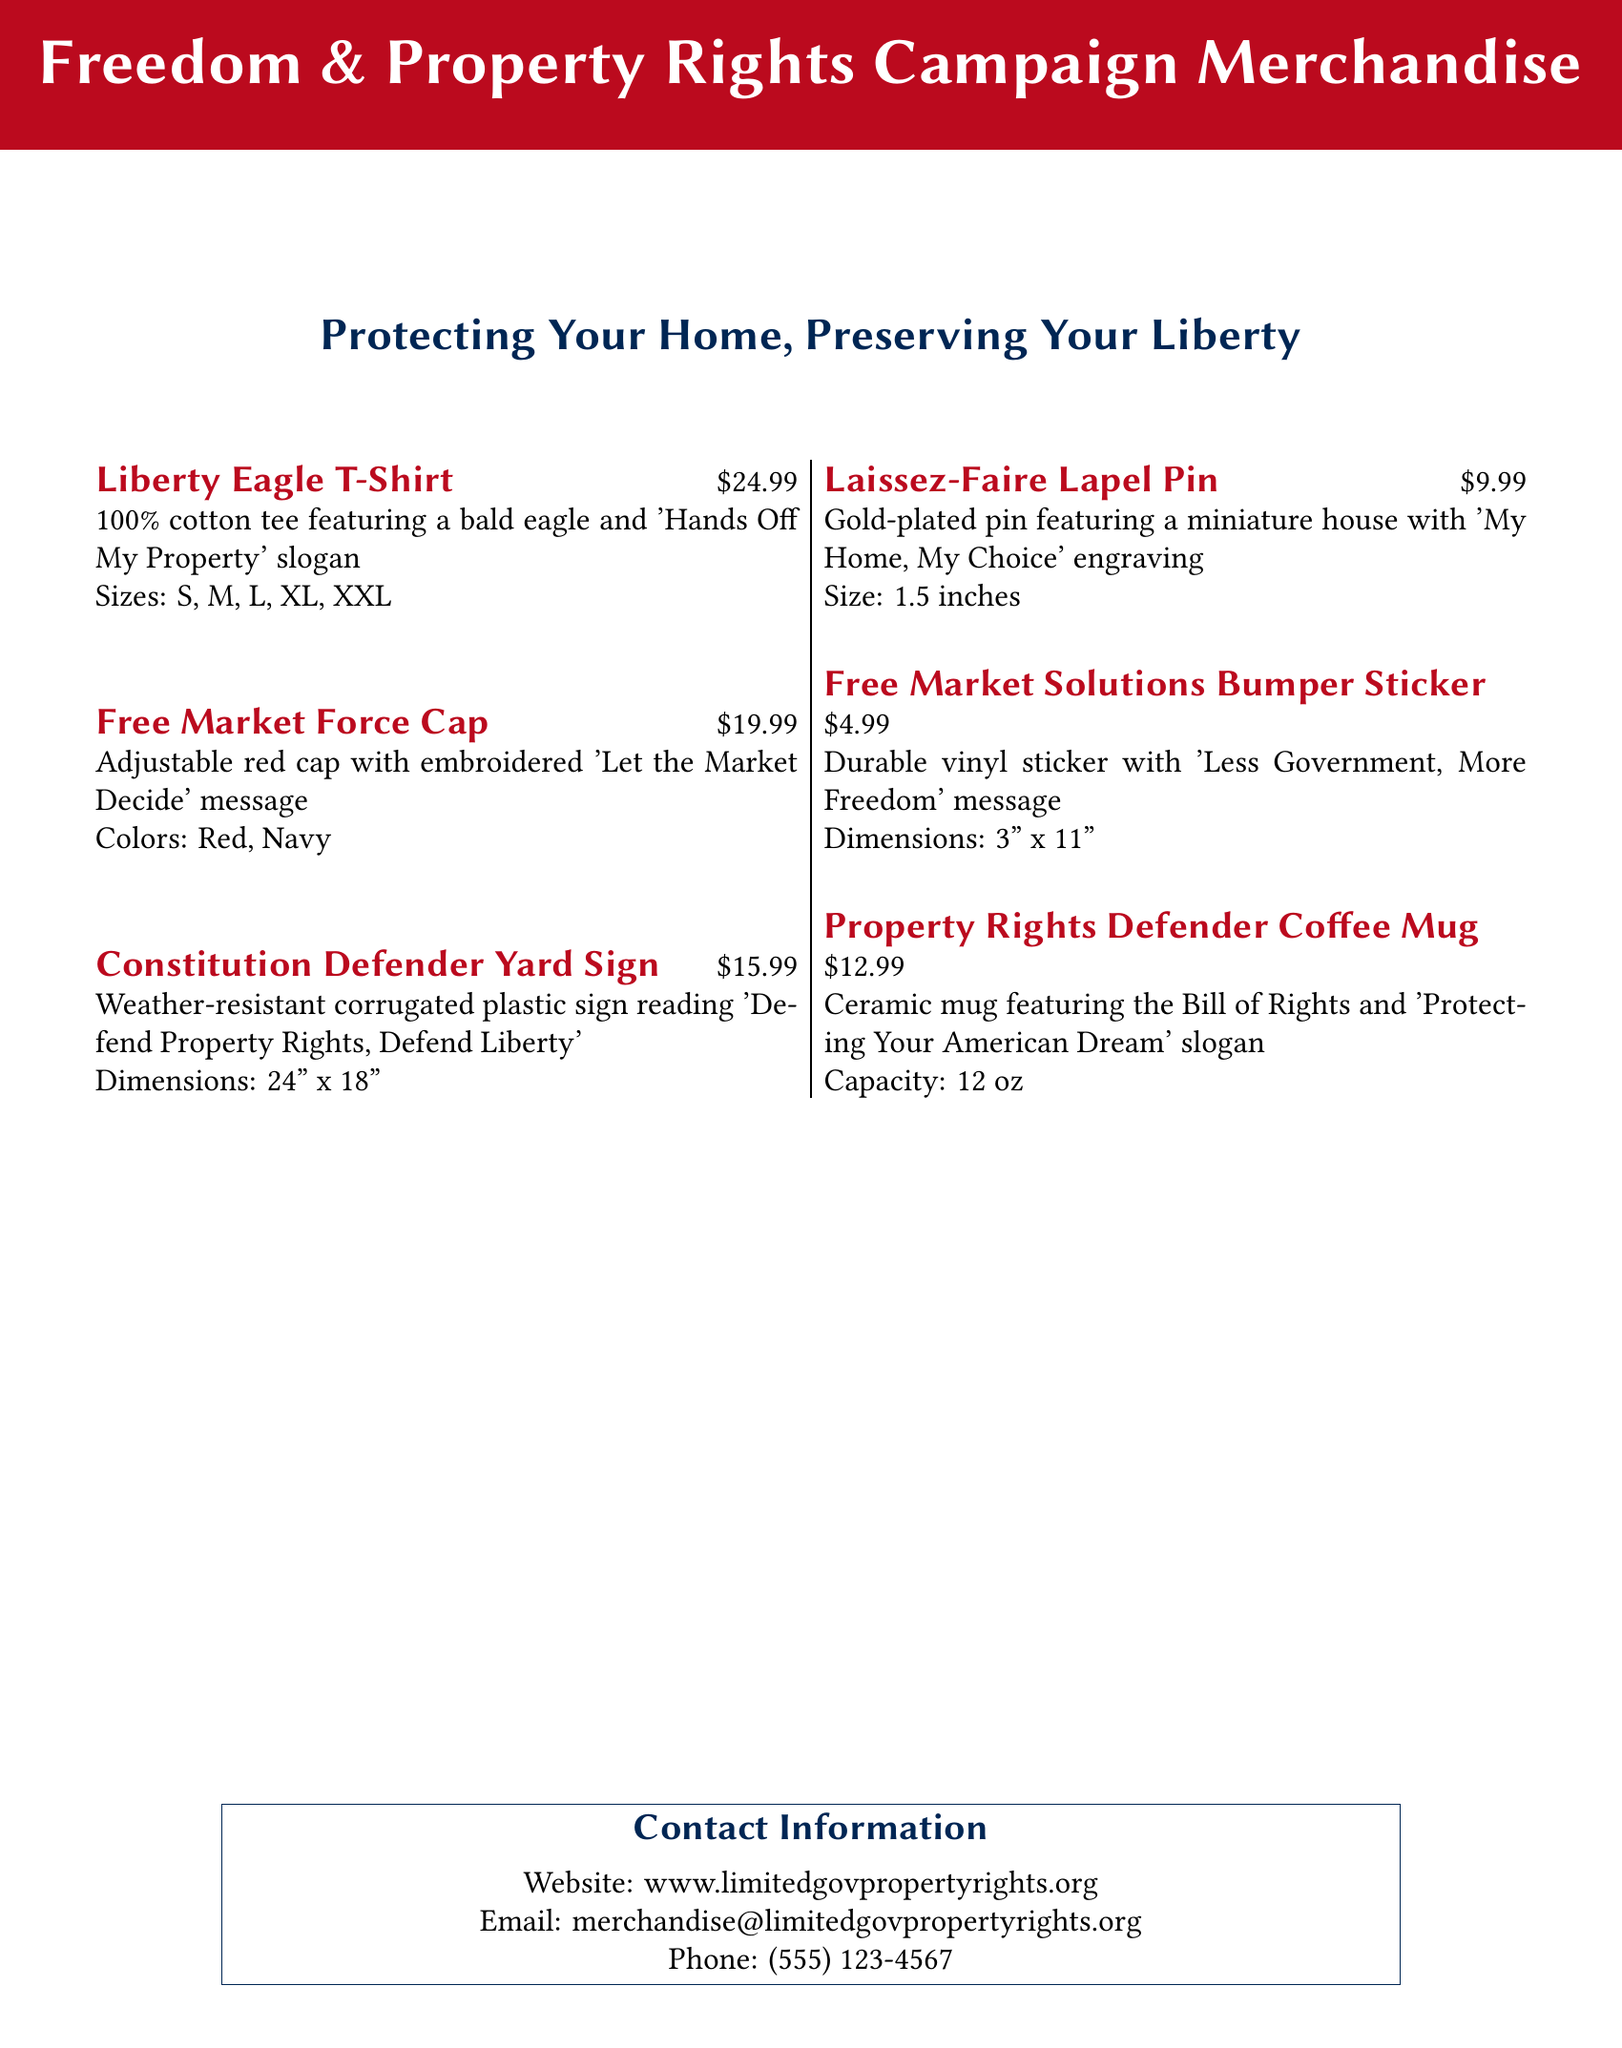What is the price of the Liberty Eagle T-Shirt? The price is explicitly stated next to the item description in the document.
Answer: $24.99 What slogan is featured on the Free Market Force Cap? The specific slogan is mentioned in the item description for the cap in the document.
Answer: Let the Market Decide What material is the Property Rights Defender Coffee Mug made from? The material is specified in the description of the coffee mug.
Answer: Ceramic How many sizes are available for the Liberty Eagle T-Shirt? The number of sizes is listed under the item description for the T-shirt.
Answer: 5 What message is on the Free Market Solutions Bumper Sticker? The message is clearly indicated in the bumper sticker's description.
Answer: Less Government, More Freedom Which item features the engraving "My Home, My Choice"? This item is detailed in the document with its description including the engraving.
Answer: Laissez-Faire Lapel Pin What is the dimension of the Constitution Defender Yard Sign? The dimensions are specified in the item description.
Answer: 24" x 18" How can I contact the organization for more information? The contact information is provided in a specific section at the bottom of the document.
Answer: merchandise@limitedgovpropertyrights.org What is the capacity of the Property Rights Defender Coffee Mug? The capacity is directly mentioned in the item's description.
Answer: 12 oz What color options are available for the Free Market Force Cap? The available colors are indicated in the description of the cap in the document.
Answer: Red, Navy 